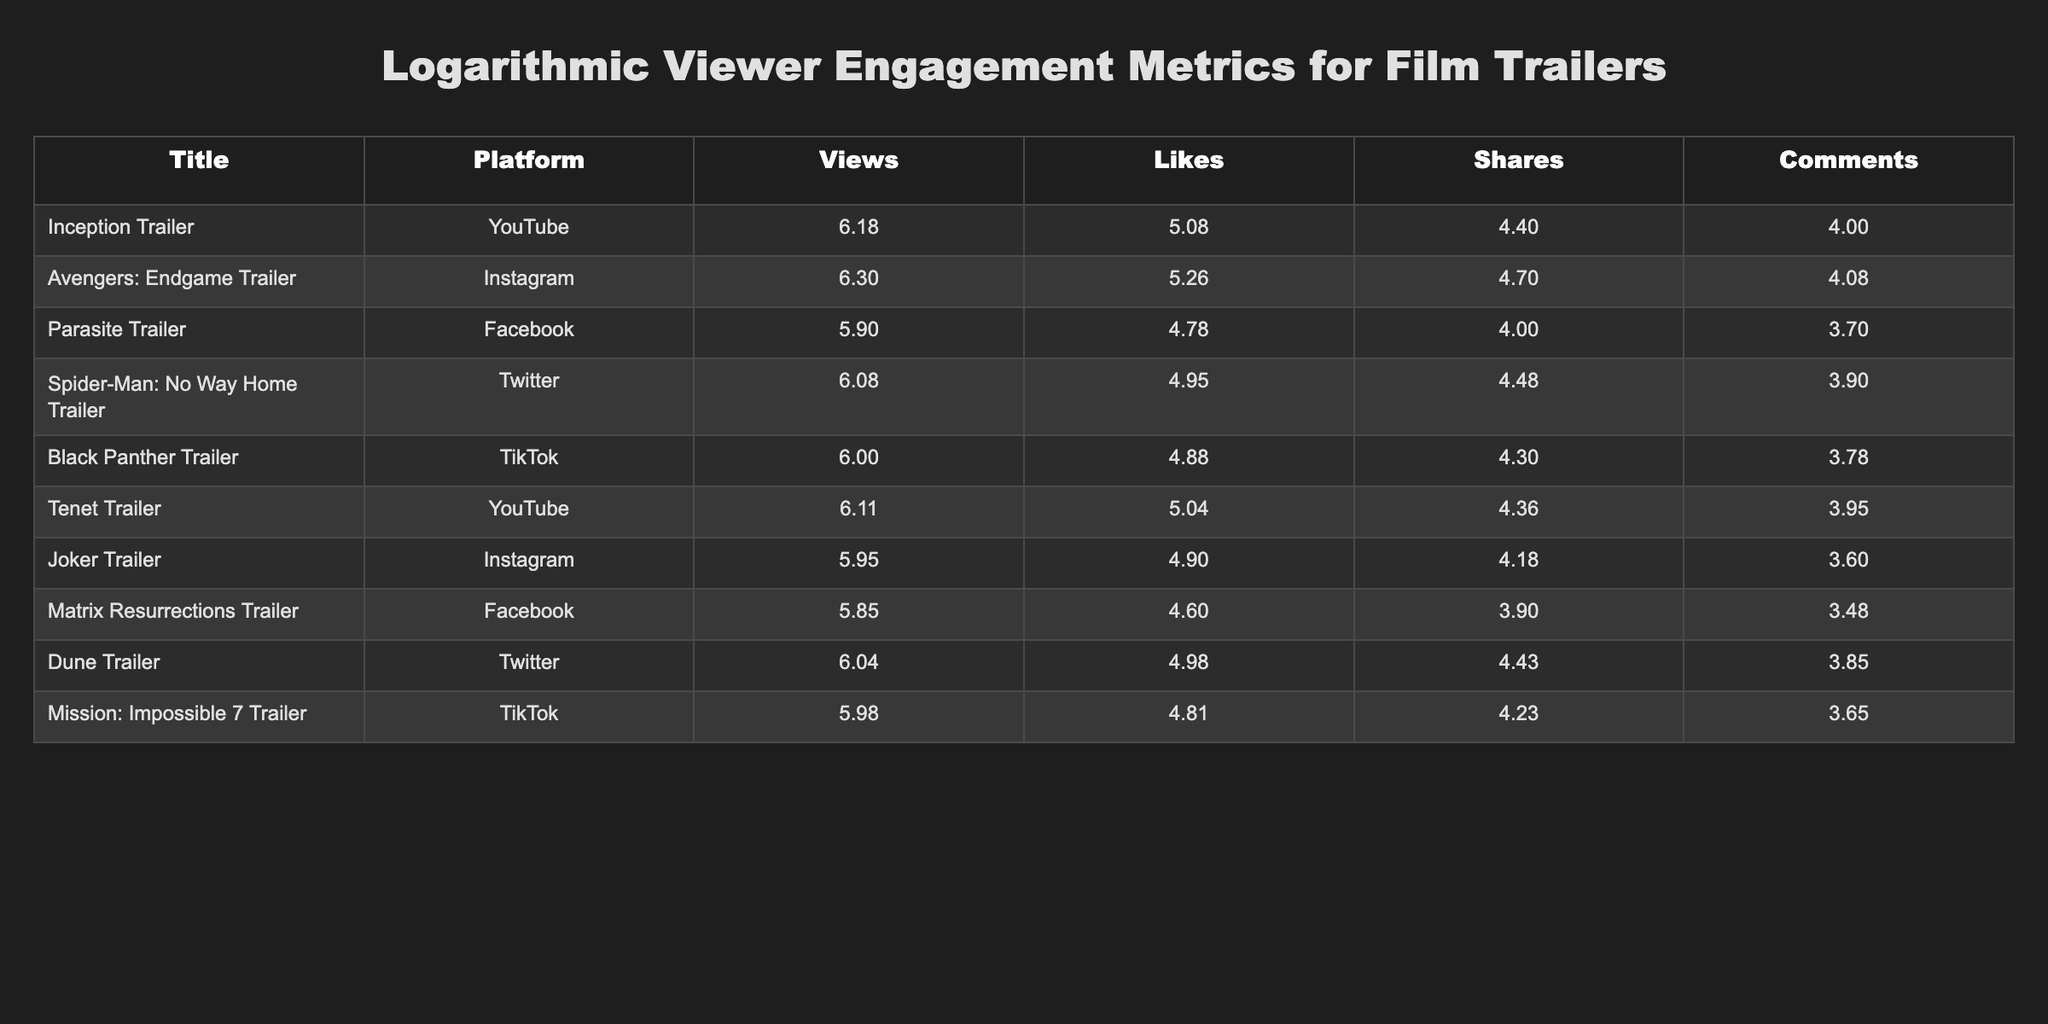What is the highest number of views recorded for a trailer in the table? The highest number of views can be found under the "Views" column by looking for the maximum value. Scanning through the values, "Avengers: Endgame Trailer" has the highest view count of 2000000.
Answer: 2000000 Which trailer has the most likes? To find the trailer with the most likes, we can look at the "Likes" column. The maximum value there belongs to "Avengers: Endgame Trailer," which has 180000 likes.
Answer: 180000 Is the number of shares for "Matrix Resurrections Trailer" greater than 15000? Checking the "Shares" column for "Matrix Resurrections Trailer," we see it has 8000 shares, which is less than 15000; therefore, the answer is no.
Answer: No What is the total number of comments for all trailers combined? To find the total number of comments, we need to sum the values in the "Comments" column: 10000 + 12000 + 5000 + 8000 + 6000 + 9000 + 4000 + 3000 + 7000 + 4500 = 60000.
Answer: 60000 Which platform had the lowest average likes for its trailers? We calculate the average likes for each platform. For YouTube: (120000 + 110000) / 2 = 115000. For Instagram: (180000 + 80000) / 2 = 130000. For Facebook: (60000 + 40000) / 2 = 50000. For Twitter: (90000 + 95000) / 2 = 92500. For TikTok: (75000 + 65000) / 2 = 70000. The lowest average is on Facebook with 50000.
Answer: Facebook Was the engagement in terms of shares for "Tenet Trailer" greater than the engagement for "Dune Trailer"? Looking at shares, "Tenet Trailer" has 23000 shares, while "Dune Trailer" has 27000. Since 23000 is less than 27000, the answer is no.
Answer: No What is the average number of views for trailers on TikTok? Calculating the average views for TikTok, we have two trailers: "Black Panther Trailer" with 1000000 views and "Mission: Impossible 7 Trailer" with 950000 views. The average is (1000000 + 950000) / 2 = 975000.
Answer: 975000 Which trailer had the lowest number of comments, and how many comments did it receive? Checking the "Comments" column for each trailer, "Matrix Resurrections Trailer" had the lowest number with 3000 comments.
Answer: Matrix Resurrections Trailer, 3000 Is there any trailer with more than 20000 likes on Twitter? By examining the likes for Twitter trailers: "Spider-Man: No Way Home Trailer" has 90000 likes and "Dune Trailer" has 95000 likes. Since both are more than 20000, the answer is yes.
Answer: Yes 